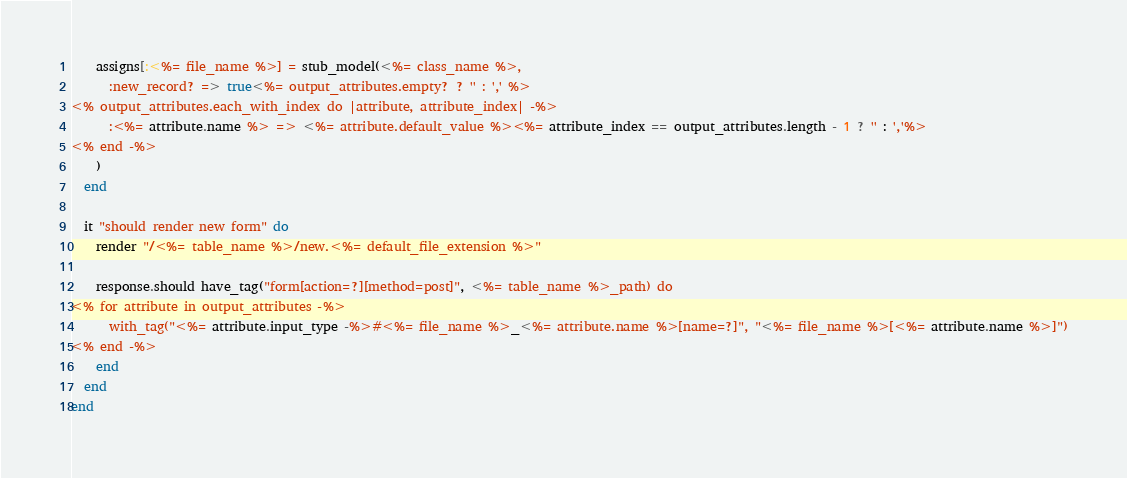Convert code to text. <code><loc_0><loc_0><loc_500><loc_500><_Ruby_>    assigns[:<%= file_name %>] = stub_model(<%= class_name %>,
      :new_record? => true<%= output_attributes.empty? ? '' : ',' %>
<% output_attributes.each_with_index do |attribute, attribute_index| -%>
      :<%= attribute.name %> => <%= attribute.default_value %><%= attribute_index == output_attributes.length - 1 ? '' : ','%>
<% end -%>
    )
  end

  it "should render new form" do
    render "/<%= table_name %>/new.<%= default_file_extension %>"
    
    response.should have_tag("form[action=?][method=post]", <%= table_name %>_path) do
<% for attribute in output_attributes -%>
      with_tag("<%= attribute.input_type -%>#<%= file_name %>_<%= attribute.name %>[name=?]", "<%= file_name %>[<%= attribute.name %>]")
<% end -%>
    end
  end
end


</code> 